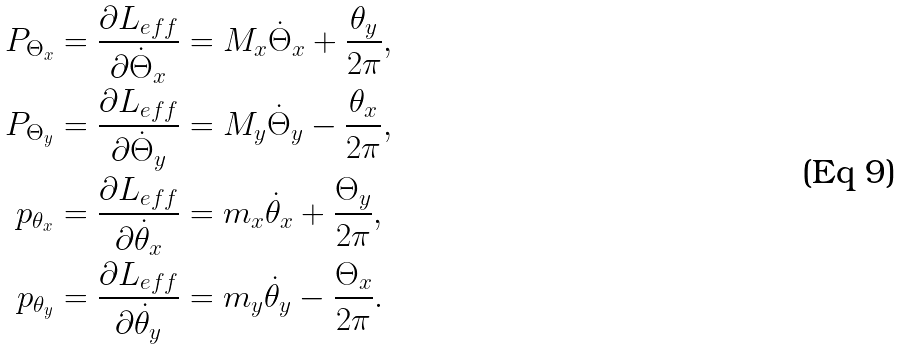<formula> <loc_0><loc_0><loc_500><loc_500>P _ { \Theta _ { x } } & = \frac { \partial L _ { e f f } } { \partial \dot { \Theta } _ { x } } = M _ { x } \dot { \Theta } _ { x } + \frac { \theta _ { y } } { 2 \pi } , \\ P _ { \Theta _ { y } } & = \frac { \partial L _ { e f f } } { \partial \dot { \Theta } _ { y } } = M _ { y } \dot { \Theta } _ { y } - \frac { \theta _ { x } } { 2 \pi } , \\ p _ { \theta _ { x } } & = \frac { \partial L _ { e f f } } { \partial \dot { \theta } _ { x } } = m _ { x } \dot { \theta } _ { x } + \frac { \Theta _ { y } } { 2 \pi } , \\ p _ { \theta _ { y } } & = \frac { \partial L _ { e f f } } { \partial \dot { \theta } _ { y } } = m _ { y } \dot { \theta } _ { y } - \frac { \Theta _ { x } } { 2 \pi } .</formula> 